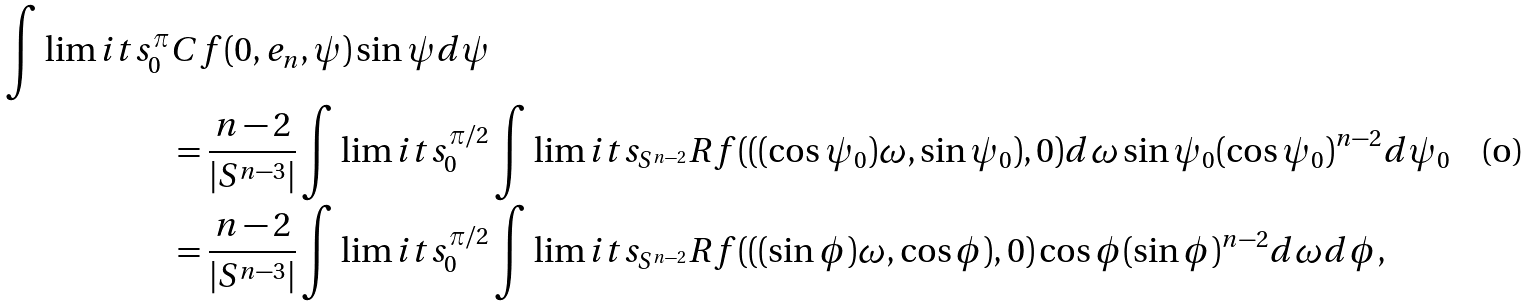<formula> <loc_0><loc_0><loc_500><loc_500>\int \lim i t s _ { 0 } ^ { \pi } & C f ( 0 , e _ { n } , \psi ) \sin \psi d \psi \\ & = \frac { n - 2 } { | S ^ { n - 3 } | } \int \lim i t s _ { 0 } ^ { \pi / 2 } \int \lim i t s _ { S ^ { n - 2 } } R f ( ( ( \cos \psi _ { 0 } ) \omega , \sin \psi _ { 0 } ) , 0 ) d \omega \sin \psi _ { 0 } ( \cos \psi _ { 0 } ) ^ { n - 2 } d \psi _ { 0 } \\ & = \frac { n - 2 } { | S ^ { n - 3 } | } \int \lim i t s _ { 0 } ^ { \pi / 2 } \int \lim i t s _ { S ^ { n - 2 } } R f ( ( ( \sin \phi ) \omega , \cos \phi ) , 0 ) \cos \phi ( \sin \phi ) ^ { n - 2 } d \omega d \phi ,</formula> 